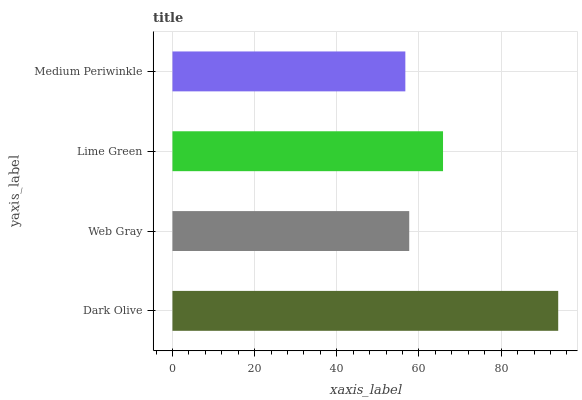Is Medium Periwinkle the minimum?
Answer yes or no. Yes. Is Dark Olive the maximum?
Answer yes or no. Yes. Is Web Gray the minimum?
Answer yes or no. No. Is Web Gray the maximum?
Answer yes or no. No. Is Dark Olive greater than Web Gray?
Answer yes or no. Yes. Is Web Gray less than Dark Olive?
Answer yes or no. Yes. Is Web Gray greater than Dark Olive?
Answer yes or no. No. Is Dark Olive less than Web Gray?
Answer yes or no. No. Is Lime Green the high median?
Answer yes or no. Yes. Is Web Gray the low median?
Answer yes or no. Yes. Is Medium Periwinkle the high median?
Answer yes or no. No. Is Lime Green the low median?
Answer yes or no. No. 